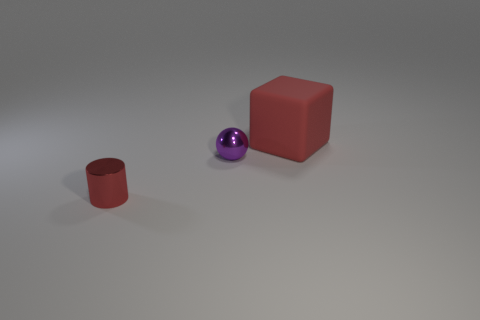Subtract all brown metallic cylinders. Subtract all tiny metallic objects. How many objects are left? 1 Add 3 small red cylinders. How many small red cylinders are left? 4 Add 3 large rubber things. How many large rubber things exist? 4 Add 2 big gray metallic things. How many objects exist? 5 Subtract 1 purple spheres. How many objects are left? 2 Subtract all balls. How many objects are left? 2 Subtract all gray blocks. Subtract all brown cylinders. How many blocks are left? 1 Subtract all brown cubes. How many green balls are left? 0 